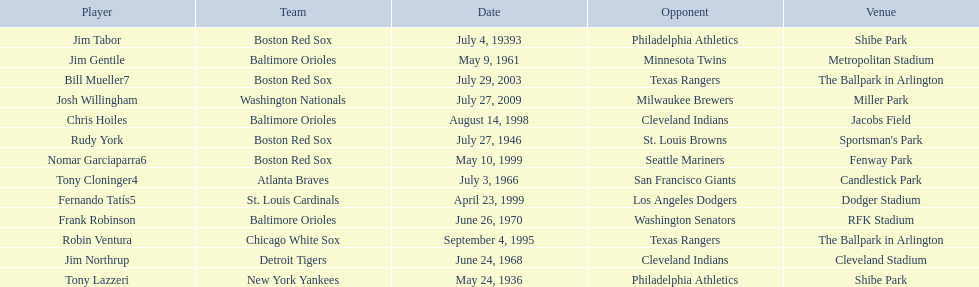What are the names of all the players? Tony Lazzeri, Jim Tabor, Rudy York, Jim Gentile, Tony Cloninger4, Jim Northrup, Frank Robinson, Robin Ventura, Chris Hoiles, Fernando Tatís5, Nomar Garciaparra6, Bill Mueller7, Josh Willingham. Write the full table. {'header': ['Player', 'Team', 'Date', 'Opponent', 'Venue'], 'rows': [['Jim Tabor', 'Boston Red Sox', 'July 4, 19393', 'Philadelphia Athletics', 'Shibe Park'], ['Jim Gentile', 'Baltimore Orioles', 'May 9, 1961', 'Minnesota Twins', 'Metropolitan Stadium'], ['Bill Mueller7', 'Boston Red Sox', 'July 29, 2003', 'Texas Rangers', 'The Ballpark in Arlington'], ['Josh Willingham', 'Washington Nationals', 'July 27, 2009', 'Milwaukee Brewers', 'Miller Park'], ['Chris Hoiles', 'Baltimore Orioles', 'August 14, 1998', 'Cleveland Indians', 'Jacobs Field'], ['Rudy York', 'Boston Red Sox', 'July 27, 1946', 'St. Louis Browns', "Sportsman's Park"], ['Nomar Garciaparra6', 'Boston Red Sox', 'May 10, 1999', 'Seattle Mariners', 'Fenway Park'], ['Tony Cloninger4', 'Atlanta Braves', 'July 3, 1966', 'San Francisco Giants', 'Candlestick Park'], ['Fernando Tatís5', 'St. Louis Cardinals', 'April 23, 1999', 'Los Angeles Dodgers', 'Dodger Stadium'], ['Frank Robinson', 'Baltimore Orioles', 'June 26, 1970', 'Washington Senators', 'RFK Stadium'], ['Robin Ventura', 'Chicago White Sox', 'September 4, 1995', 'Texas Rangers', 'The Ballpark in Arlington'], ['Jim Northrup', 'Detroit Tigers', 'June 24, 1968', 'Cleveland Indians', 'Cleveland Stadium'], ['Tony Lazzeri', 'New York Yankees', 'May 24, 1936', 'Philadelphia Athletics', 'Shibe Park']]} What are the names of all the teams holding home run records? New York Yankees, Boston Red Sox, Baltimore Orioles, Atlanta Braves, Detroit Tigers, Chicago White Sox, St. Louis Cardinals, Washington Nationals. Which player played for the new york yankees? Tony Lazzeri. 